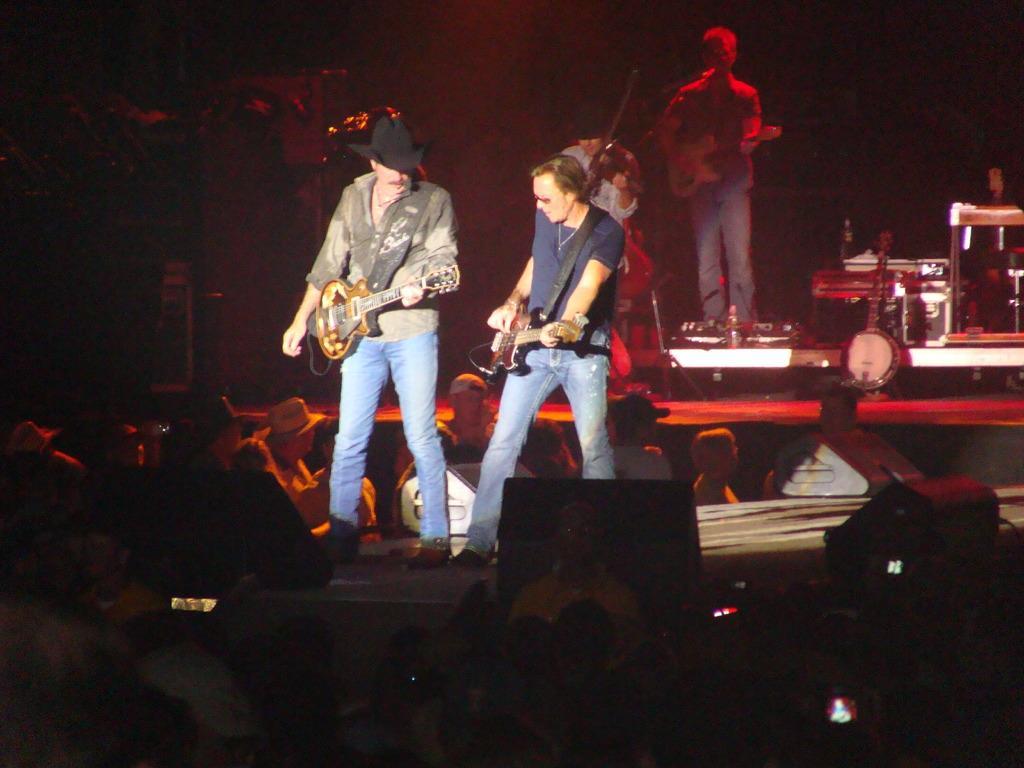Please provide a concise description of this image. It seems like a musical concert is going on. Few people are playing guitar on the stage. On the stage there are few other instruments. In front of them people are standing. 